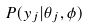<formula> <loc_0><loc_0><loc_500><loc_500>P ( y _ { j } | \theta _ { j } , \phi )</formula> 